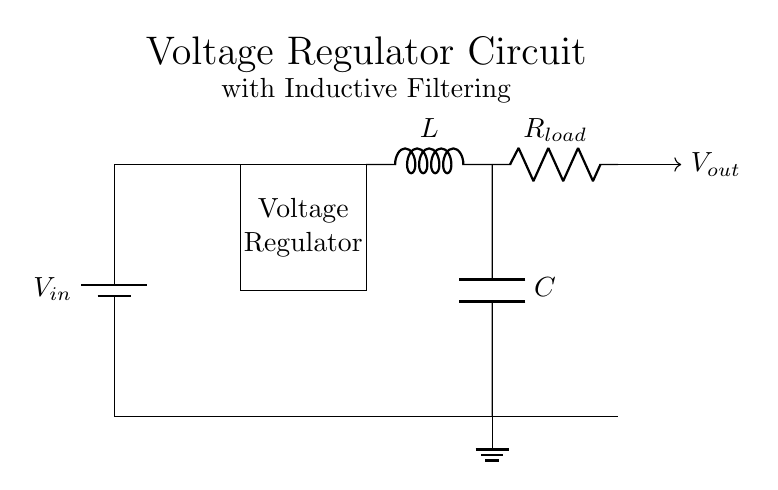What type of filter is used in this circuit? The circuit uses an inductor filter, indicated by the symbol "L." Inductors are commonly used to smooth out fluctuations in voltage by resisting changes in current.
Answer: Inductor What is the component that provides the output voltage? The output voltage is provided by the load resistor, which is noted as "R load." This component carries the current and experiences the voltage drop that relates to the output.
Answer: R load What is the role of the capacitor in this circuit? The capacitor, denoted as "C," is used for energy storage and helps to filter out voltage fluctuations, smoothing the output voltage. It works in conjunction with the inductor to enhance stability.
Answer: Filters voltage What connects the inductor to the voltage regulator? A wire connects the inductor directly to the voltage regulator, indicated by the lines running between them. This connection allows current to flow from the voltage regulator through the inductor to the output.
Answer: Wire How does the inductor influence the output voltage? The inductor resists sudden changes in current, which helps to stabilize the output voltage during transient events. This property influences the overall performance of the voltage regulator circuit.
Answer: Stabilizes output What is the input voltage symbol in this circuit? The input voltage is represented by "V in," noted by the battery symbol at the top. This symbol shows the source of potential difference that powers the circuit.
Answer: V in What function does the voltage regulator serve in this circuit? The voltage regulator ensures that the output voltage remains constant despite variations in input voltage or load conditions. It adjusts the output to a desired level, thus protecting the sensitive measurement devices.
Answer: Regulates voltage 